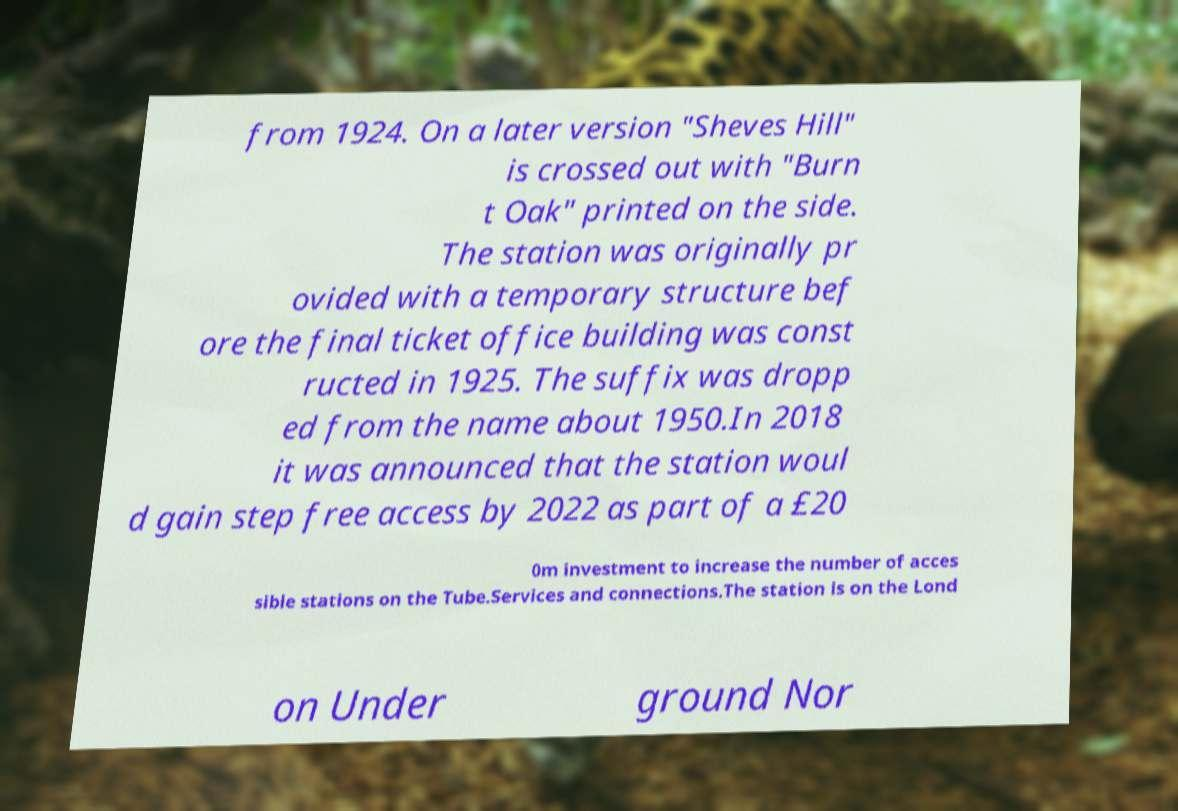There's text embedded in this image that I need extracted. Can you transcribe it verbatim? from 1924. On a later version "Sheves Hill" is crossed out with "Burn t Oak" printed on the side. The station was originally pr ovided with a temporary structure bef ore the final ticket office building was const ructed in 1925. The suffix was dropp ed from the name about 1950.In 2018 it was announced that the station woul d gain step free access by 2022 as part of a £20 0m investment to increase the number of acces sible stations on the Tube.Services and connections.The station is on the Lond on Under ground Nor 